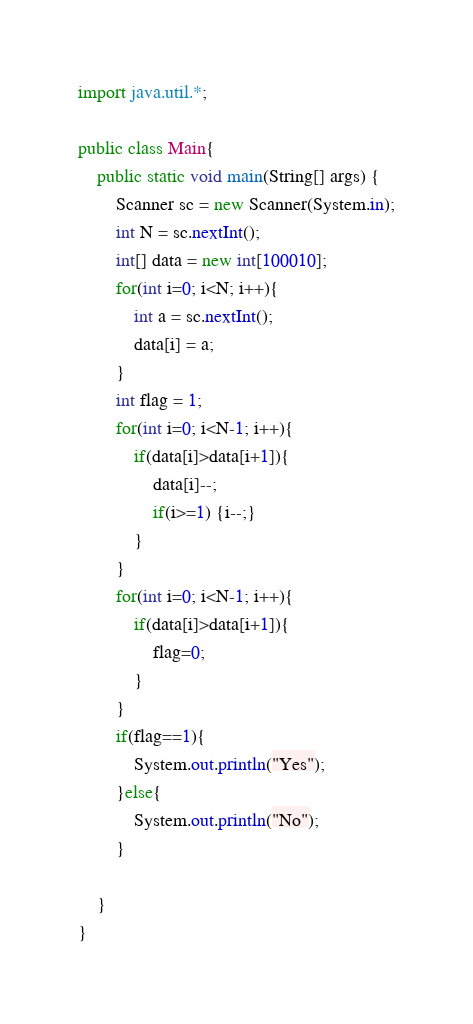Convert code to text. <code><loc_0><loc_0><loc_500><loc_500><_Java_>import java.util.*;

public class Main{
    public static void main(String[] args) {
        Scanner sc = new Scanner(System.in);
        int N = sc.nextInt();
        int[] data = new int[100010];
        for(int i=0; i<N; i++){
            int a = sc.nextInt();
            data[i] = a;
        }
        int flag = 1;
        for(int i=0; i<N-1; i++){
            if(data[i]>data[i+1]){
                data[i]--;
                if(i>=1) {i--;}
            }
        }
        for(int i=0; i<N-1; i++){
            if(data[i]>data[i+1]){
                flag=0;
            }
        }
        if(flag==1){
            System.out.println("Yes");
        }else{
            System.out.println("No");
        }
        
    }
}</code> 